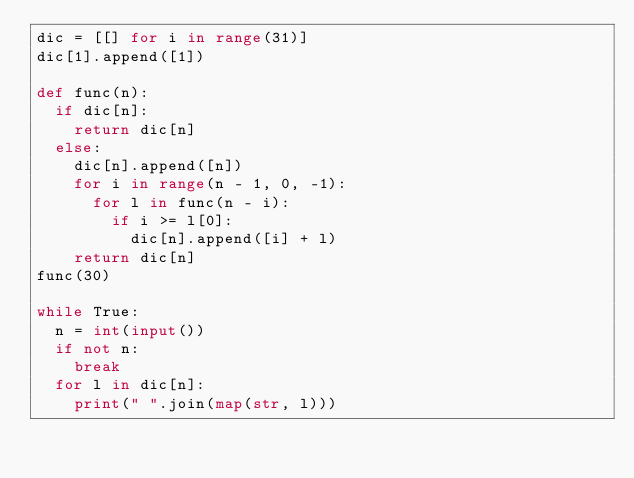<code> <loc_0><loc_0><loc_500><loc_500><_Python_>dic = [[] for i in range(31)]
dic[1].append([1])

def func(n):
  if dic[n]:
    return dic[n]
  else:
    dic[n].append([n])
    for i in range(n - 1, 0, -1):
      for l in func(n - i):
        if i >= l[0]:
          dic[n].append([i] + l)
    return dic[n]
func(30)

while True:
  n = int(input())
  if not n:
    break
  for l in dic[n]:
    print(" ".join(map(str, l)))
</code> 